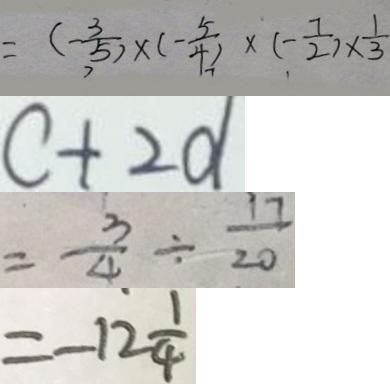<formula> <loc_0><loc_0><loc_500><loc_500>= ( - \frac { 3 } { 5 } ) \times ( - \frac { 5 } { 4 } ) \times ( - \frac { 7 } { 2 } ) \times \frac { 1 } { 3 } 
 c + 2 d 
 = \frac { 3 } { 4 } \div \frac { 1 7 } { 2 0 } 
 = - 1 2 \frac { 1 } { 4 }</formula> 